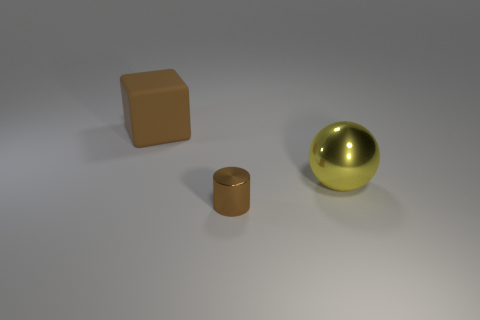Add 3 purple cubes. How many objects exist? 6 Subtract all blocks. How many objects are left? 2 Add 2 yellow metal objects. How many yellow metal objects exist? 3 Subtract 0 red balls. How many objects are left? 3 Subtract all spheres. Subtract all matte blocks. How many objects are left? 1 Add 1 big yellow balls. How many big yellow balls are left? 2 